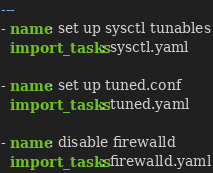Convert code to text. <code><loc_0><loc_0><loc_500><loc_500><_YAML_>---
- name: set up sysctl tunables
  import_tasks: sysctl.yaml

- name: set up tuned.conf
  import_tasks: tuned.yaml

- name: disable firewalld
  import_tasks: firewalld.yaml
</code> 